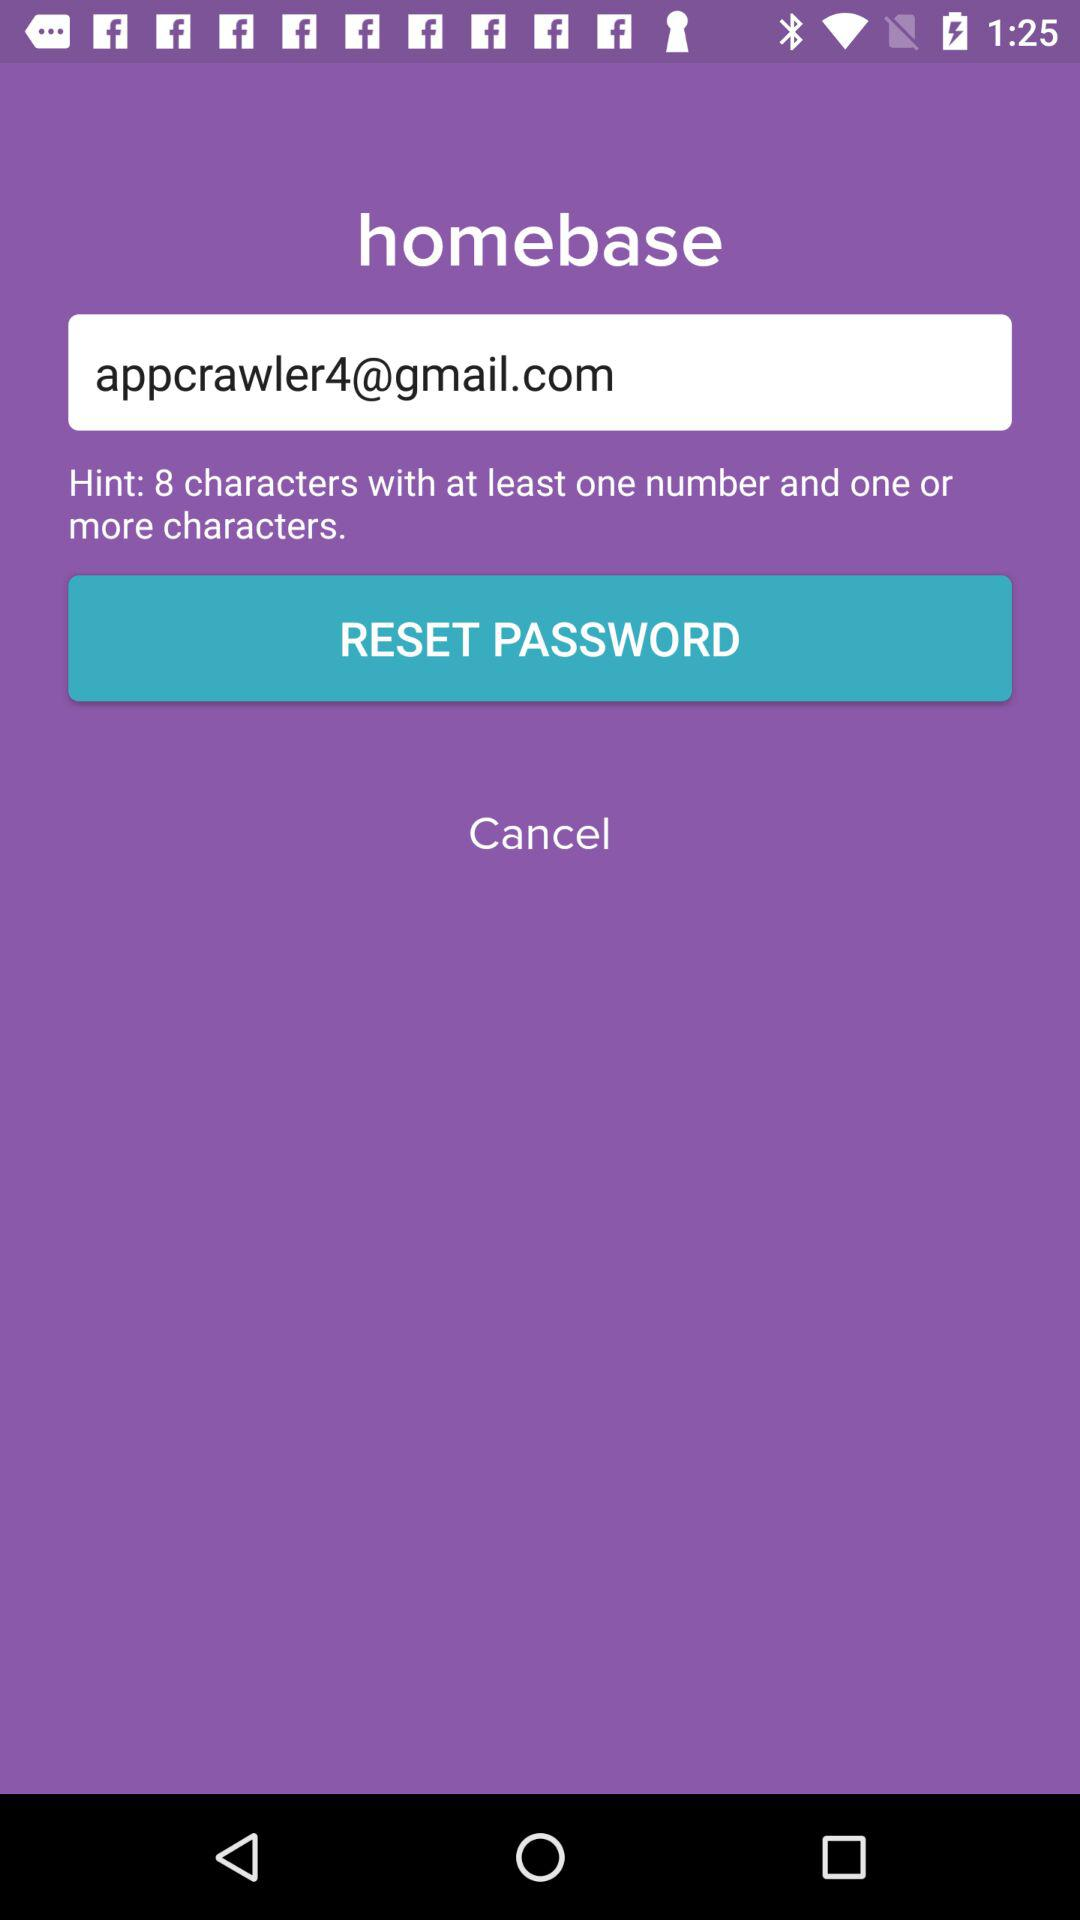What is the application name? The application name is "homebase". 